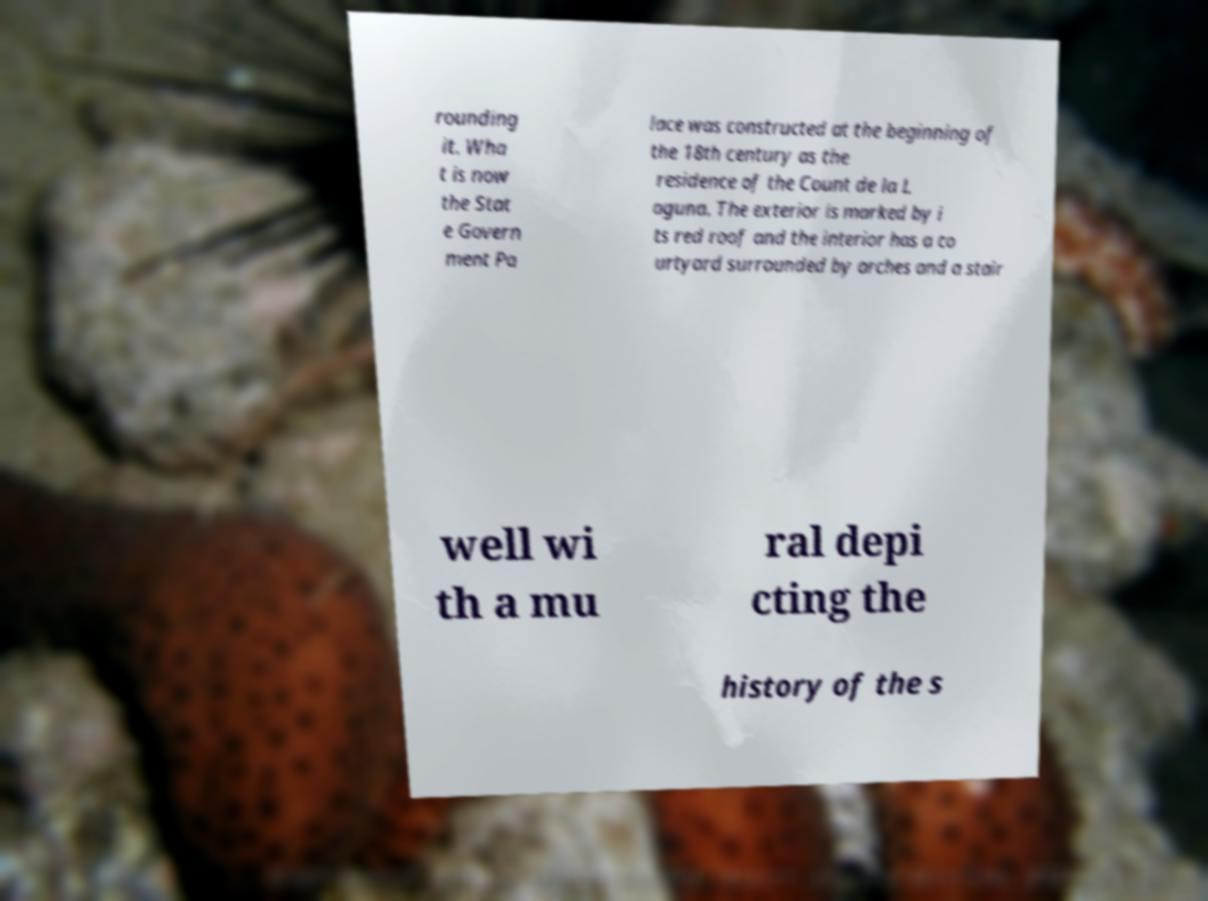I need the written content from this picture converted into text. Can you do that? rounding it. Wha t is now the Stat e Govern ment Pa lace was constructed at the beginning of the 18th century as the residence of the Count de la L aguna. The exterior is marked by i ts red roof and the interior has a co urtyard surrounded by arches and a stair well wi th a mu ral depi cting the history of the s 